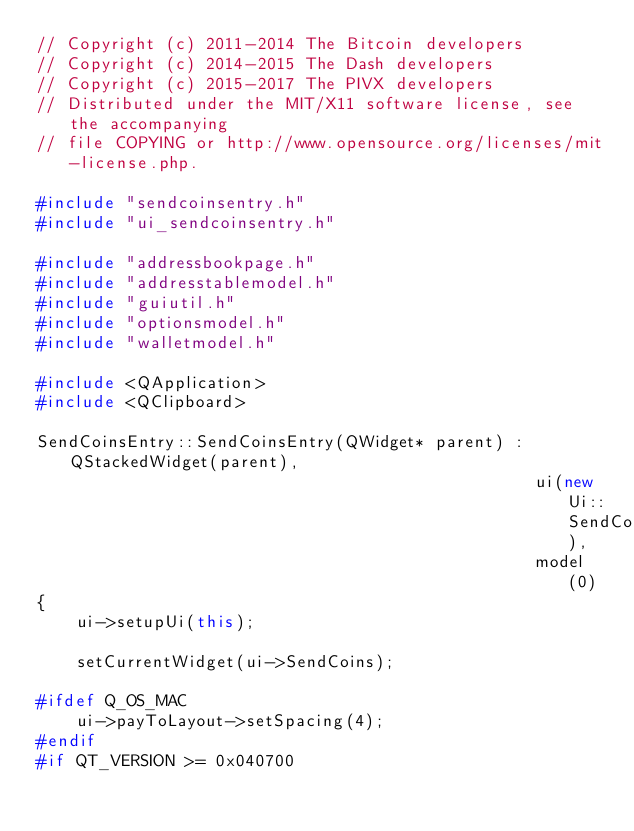Convert code to text. <code><loc_0><loc_0><loc_500><loc_500><_C++_>// Copyright (c) 2011-2014 The Bitcoin developers
// Copyright (c) 2014-2015 The Dash developers
// Copyright (c) 2015-2017 The PIVX developers
// Distributed under the MIT/X11 software license, see the accompanying
// file COPYING or http://www.opensource.org/licenses/mit-license.php.

#include "sendcoinsentry.h"
#include "ui_sendcoinsentry.h"

#include "addressbookpage.h"
#include "addresstablemodel.h"
#include "guiutil.h"
#include "optionsmodel.h"
#include "walletmodel.h"

#include <QApplication>
#include <QClipboard>

SendCoinsEntry::SendCoinsEntry(QWidget* parent) : QStackedWidget(parent),
                                                  ui(new Ui::SendCoinsEntry),
                                                  model(0)
{
    ui->setupUi(this);

    setCurrentWidget(ui->SendCoins);

#ifdef Q_OS_MAC
    ui->payToLayout->setSpacing(4);
#endif
#if QT_VERSION >= 0x040700</code> 